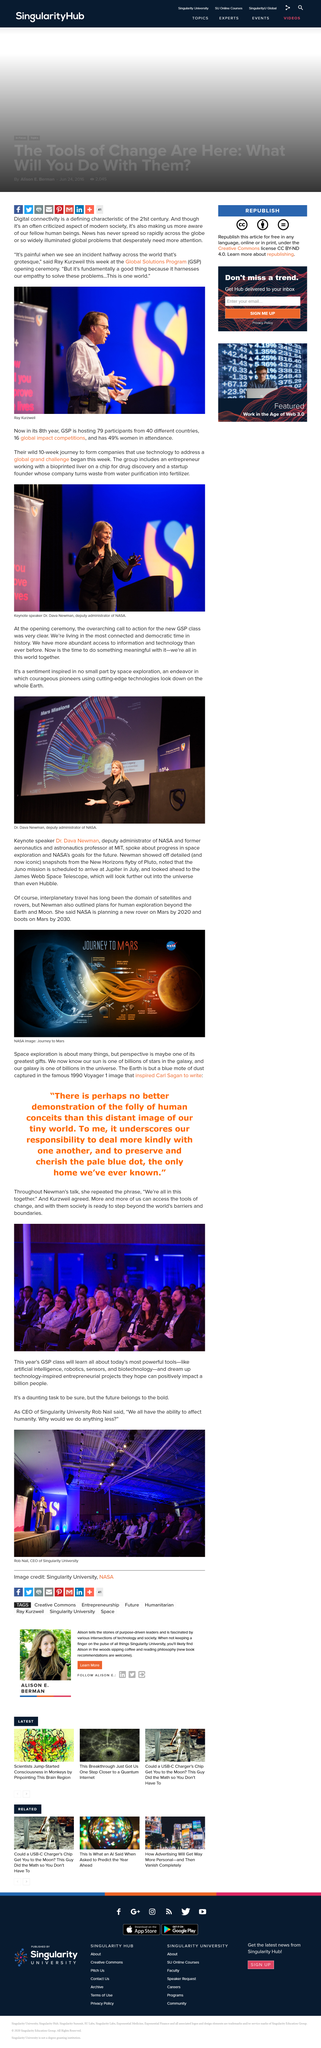Draw attention to some important aspects in this diagram. Yes, our galaxy is one of billions in the universe. The sentiment of the overall call to action was inspired by space exploration. GSP stands for Global Solutions Program, a program that aims to provide global solutions to various issues and challenges faced by individuals and communities worldwide. The name of the man in the image is Ray Kurzweil. Digital connectivity is a defining characteristic of the 21st century, enabling individuals and societies to communicate and exchange information instantaneously across the globe. 